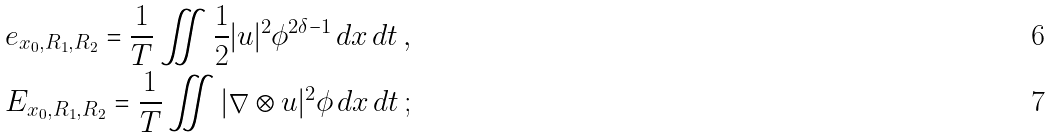<formula> <loc_0><loc_0><loc_500><loc_500>& e _ { x _ { 0 } , R _ { 1 } , R _ { 2 } } = \frac { 1 } { T } \iint \frac { 1 } { 2 } | u | ^ { 2 } \phi ^ { 2 \delta - 1 } \, d x \, d t \, , \\ & E _ { x _ { 0 } , R _ { 1 } , R _ { 2 } } = \frac { 1 } { T } \iint | \nabla \otimes u | ^ { 2 } \phi \, d x \, d t \, ;</formula> 